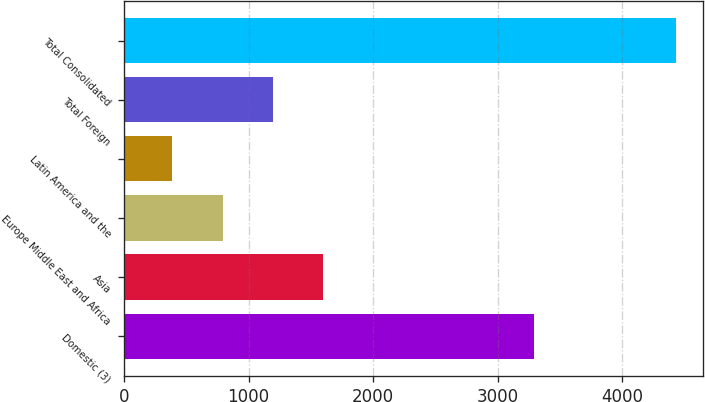<chart> <loc_0><loc_0><loc_500><loc_500><bar_chart><fcel>Domestic (3)<fcel>Asia<fcel>Europe Middle East and Africa<fcel>Latin America and the<fcel>Total Foreign<fcel>Total Consolidated<nl><fcel>3289<fcel>1600<fcel>792<fcel>388<fcel>1196<fcel>4428<nl></chart> 